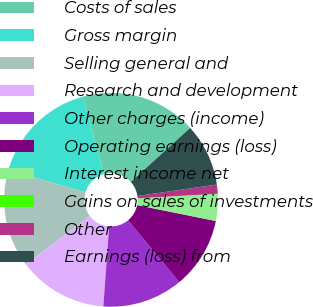Convert chart. <chart><loc_0><loc_0><loc_500><loc_500><pie_chart><fcel>Costs of sales<fcel>Gross margin<fcel>Selling general and<fcel>Research and development<fcel>Other charges (income)<fcel>Operating earnings (loss)<fcel>Interest income net<fcel>Gains on sales of investments<fcel>Other<fcel>Earnings (loss) from<nl><fcel>17.55%<fcel>16.2%<fcel>14.86%<fcel>13.51%<fcel>12.16%<fcel>10.81%<fcel>4.07%<fcel>0.02%<fcel>1.37%<fcel>9.46%<nl></chart> 